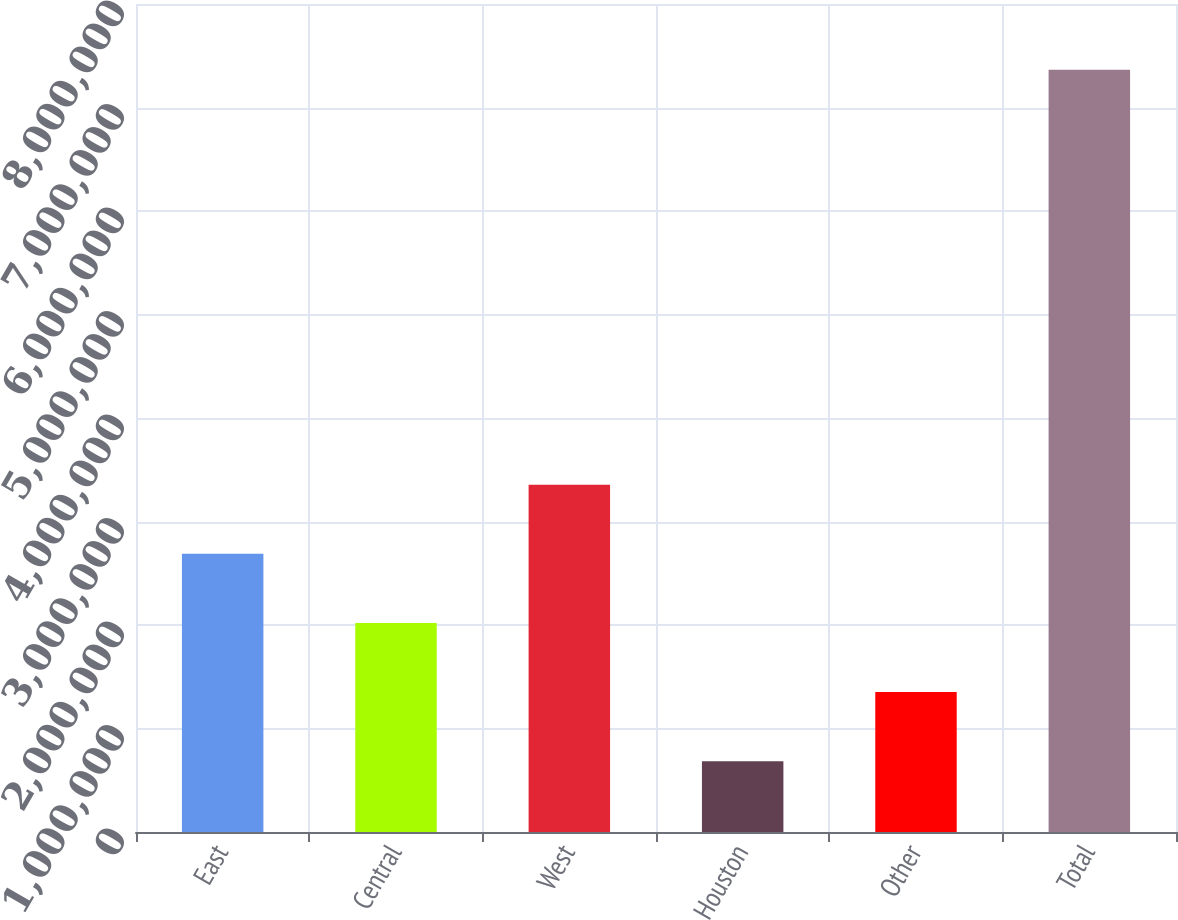Convert chart. <chart><loc_0><loc_0><loc_500><loc_500><bar_chart><fcel>East<fcel>Central<fcel>West<fcel>Houston<fcel>Other<fcel>Total<nl><fcel>2.68782e+06<fcel>2.01974e+06<fcel>3.35588e+06<fcel>683605<fcel>1.35168e+06<fcel>7.3643e+06<nl></chart> 